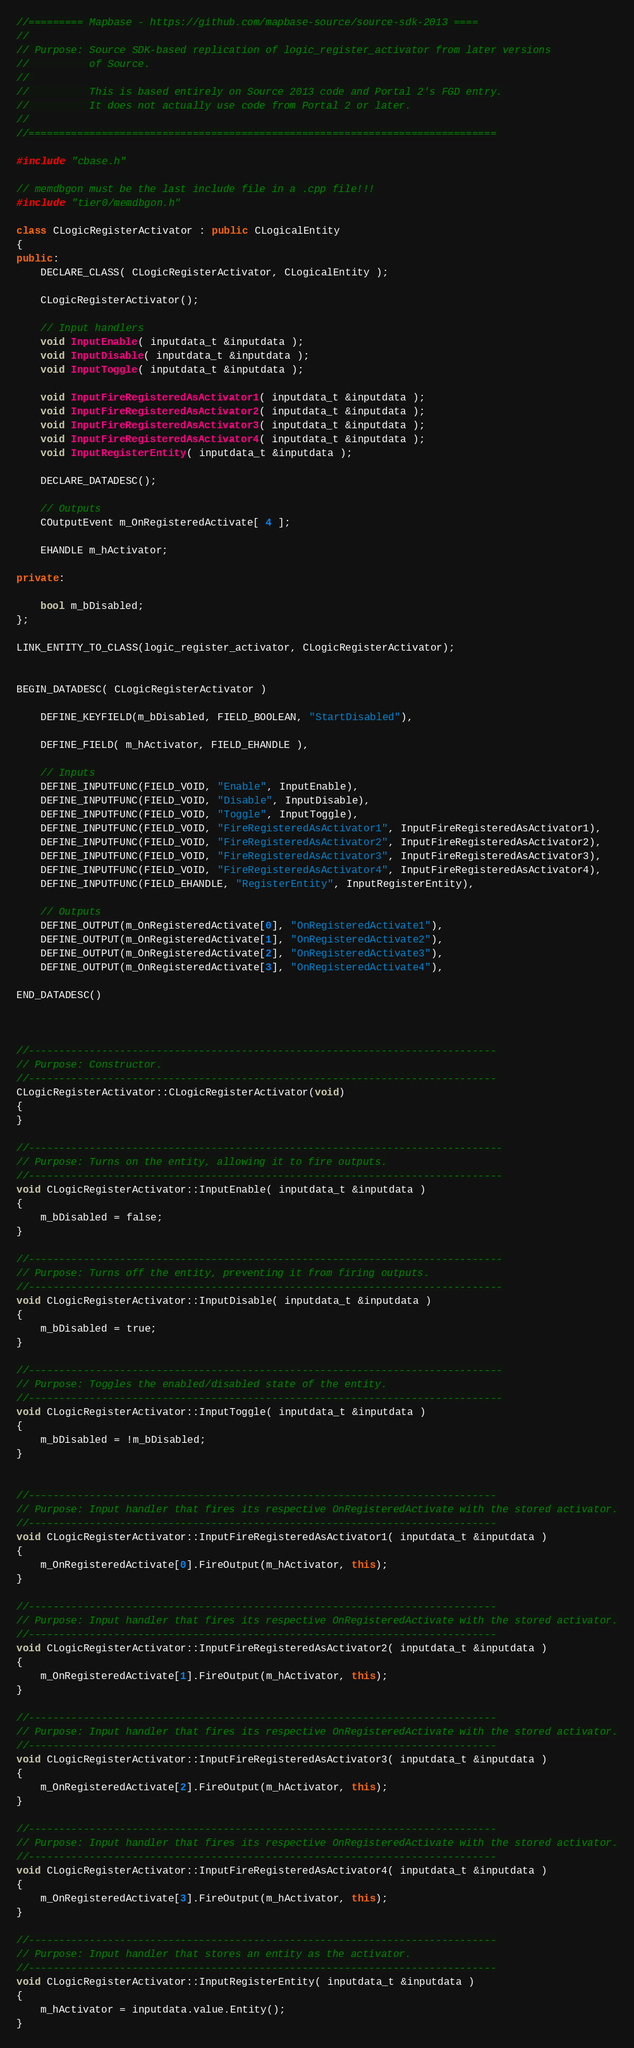<code> <loc_0><loc_0><loc_500><loc_500><_C++_>//========= Mapbase - https://github.com/mapbase-source/source-sdk-2013 ====
//
// Purpose: Source SDK-based replication of logic_register_activator from later versions
//			of Source.
// 
//			This is based entirely on Source 2013 code and Portal 2's FGD entry.
//			It does not actually use code from Portal 2 or later.
//
//=============================================================================

#include "cbase.h"

// memdbgon must be the last include file in a .cpp file!!!
#include "tier0/memdbgon.h"

class CLogicRegisterActivator : public CLogicalEntity
{
public:
	DECLARE_CLASS( CLogicRegisterActivator, CLogicalEntity );

	CLogicRegisterActivator();

	// Input handlers
	void InputEnable( inputdata_t &inputdata );
	void InputDisable( inputdata_t &inputdata );
	void InputToggle( inputdata_t &inputdata );

	void InputFireRegisteredAsActivator1( inputdata_t &inputdata );
	void InputFireRegisteredAsActivator2( inputdata_t &inputdata );
	void InputFireRegisteredAsActivator3( inputdata_t &inputdata );
	void InputFireRegisteredAsActivator4( inputdata_t &inputdata );
	void InputRegisterEntity( inputdata_t &inputdata );

	DECLARE_DATADESC();

	// Outputs
	COutputEvent m_OnRegisteredActivate[ 4 ];

	EHANDLE m_hActivator;
	
private:

	bool m_bDisabled;
};

LINK_ENTITY_TO_CLASS(logic_register_activator, CLogicRegisterActivator);


BEGIN_DATADESC( CLogicRegisterActivator )

	DEFINE_KEYFIELD(m_bDisabled, FIELD_BOOLEAN, "StartDisabled"),

	DEFINE_FIELD( m_hActivator, FIELD_EHANDLE ),

	// Inputs
	DEFINE_INPUTFUNC(FIELD_VOID, "Enable", InputEnable),
	DEFINE_INPUTFUNC(FIELD_VOID, "Disable", InputDisable),
	DEFINE_INPUTFUNC(FIELD_VOID, "Toggle", InputToggle),
	DEFINE_INPUTFUNC(FIELD_VOID, "FireRegisteredAsActivator1", InputFireRegisteredAsActivator1),
	DEFINE_INPUTFUNC(FIELD_VOID, "FireRegisteredAsActivator2", InputFireRegisteredAsActivator2),
	DEFINE_INPUTFUNC(FIELD_VOID, "FireRegisteredAsActivator3", InputFireRegisteredAsActivator3),
	DEFINE_INPUTFUNC(FIELD_VOID, "FireRegisteredAsActivator4", InputFireRegisteredAsActivator4),
	DEFINE_INPUTFUNC(FIELD_EHANDLE, "RegisterEntity", InputRegisterEntity),

	// Outputs
	DEFINE_OUTPUT(m_OnRegisteredActivate[0], "OnRegisteredActivate1"),
	DEFINE_OUTPUT(m_OnRegisteredActivate[1], "OnRegisteredActivate2"),
	DEFINE_OUTPUT(m_OnRegisteredActivate[2], "OnRegisteredActivate3"),
	DEFINE_OUTPUT(m_OnRegisteredActivate[3], "OnRegisteredActivate4"),

END_DATADESC()



//-----------------------------------------------------------------------------
// Purpose: Constructor.
//-----------------------------------------------------------------------------
CLogicRegisterActivator::CLogicRegisterActivator(void)
{
}

//------------------------------------------------------------------------------
// Purpose: Turns on the entity, allowing it to fire outputs.
//------------------------------------------------------------------------------
void CLogicRegisterActivator::InputEnable( inputdata_t &inputdata )
{
	m_bDisabled = false;
}

//------------------------------------------------------------------------------
// Purpose: Turns off the entity, preventing it from firing outputs.
//------------------------------------------------------------------------------
void CLogicRegisterActivator::InputDisable( inputdata_t &inputdata )
{ 
	m_bDisabled = true;
}

//------------------------------------------------------------------------------
// Purpose: Toggles the enabled/disabled state of the entity.
//------------------------------------------------------------------------------
void CLogicRegisterActivator::InputToggle( inputdata_t &inputdata )
{ 
	m_bDisabled = !m_bDisabled;
}


//-----------------------------------------------------------------------------
// Purpose: Input handler that fires its respective OnRegisteredActivate with the stored activator.
//-----------------------------------------------------------------------------
void CLogicRegisterActivator::InputFireRegisteredAsActivator1( inputdata_t &inputdata )
{
	m_OnRegisteredActivate[0].FireOutput(m_hActivator, this);
}

//-----------------------------------------------------------------------------
// Purpose: Input handler that fires its respective OnRegisteredActivate with the stored activator.
//-----------------------------------------------------------------------------
void CLogicRegisterActivator::InputFireRegisteredAsActivator2( inputdata_t &inputdata )
{
	m_OnRegisteredActivate[1].FireOutput(m_hActivator, this);
}

//-----------------------------------------------------------------------------
// Purpose: Input handler that fires its respective OnRegisteredActivate with the stored activator.
//-----------------------------------------------------------------------------
void CLogicRegisterActivator::InputFireRegisteredAsActivator3( inputdata_t &inputdata )
{
	m_OnRegisteredActivate[2].FireOutput(m_hActivator, this);
}

//-----------------------------------------------------------------------------
// Purpose: Input handler that fires its respective OnRegisteredActivate with the stored activator.
//-----------------------------------------------------------------------------
void CLogicRegisterActivator::InputFireRegisteredAsActivator4( inputdata_t &inputdata )
{
	m_OnRegisteredActivate[3].FireOutput(m_hActivator, this);
}

//-----------------------------------------------------------------------------
// Purpose: Input handler that stores an entity as the activator.
//-----------------------------------------------------------------------------
void CLogicRegisterActivator::InputRegisterEntity( inputdata_t &inputdata )
{
	m_hActivator = inputdata.value.Entity();
}
</code> 